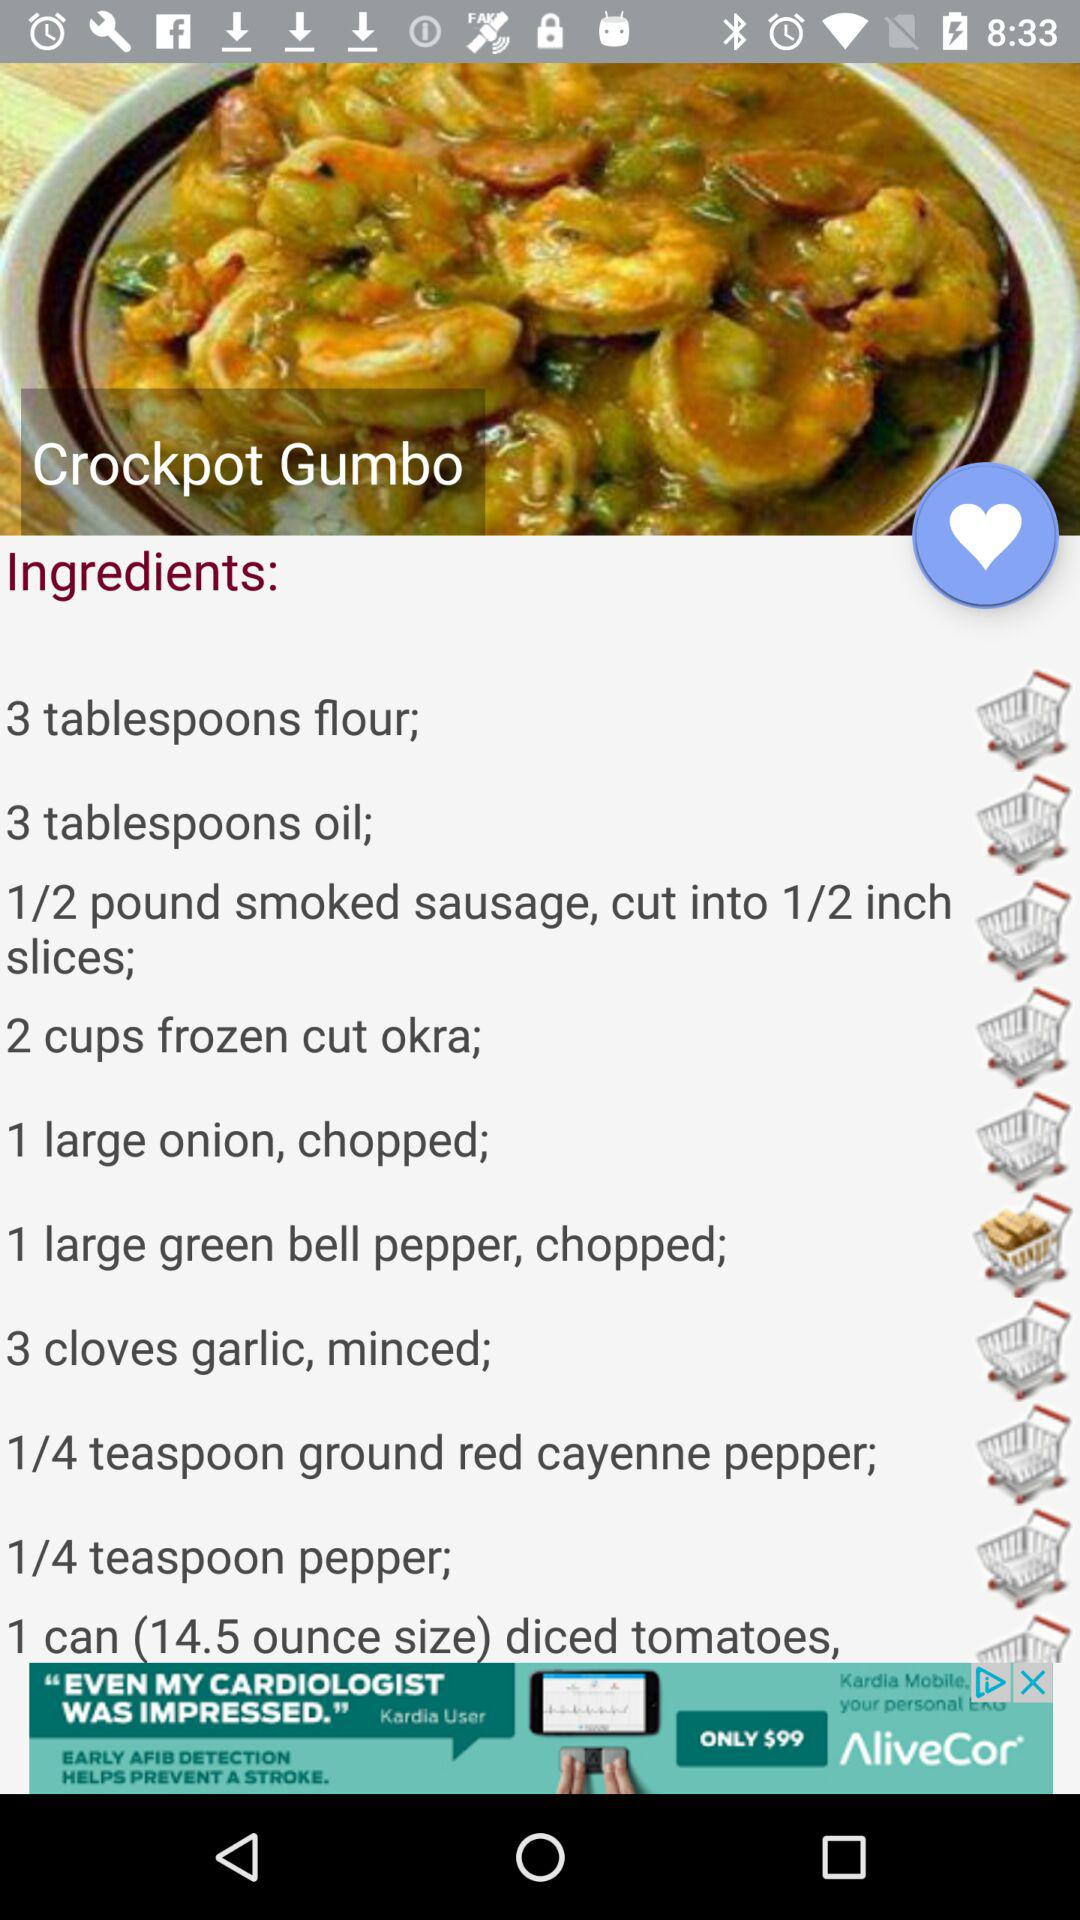How many tablespoons of oil are used in making Crockpot Gumbo? There are 3 tablespoons of oil used in making Crockpot Gumbo. 